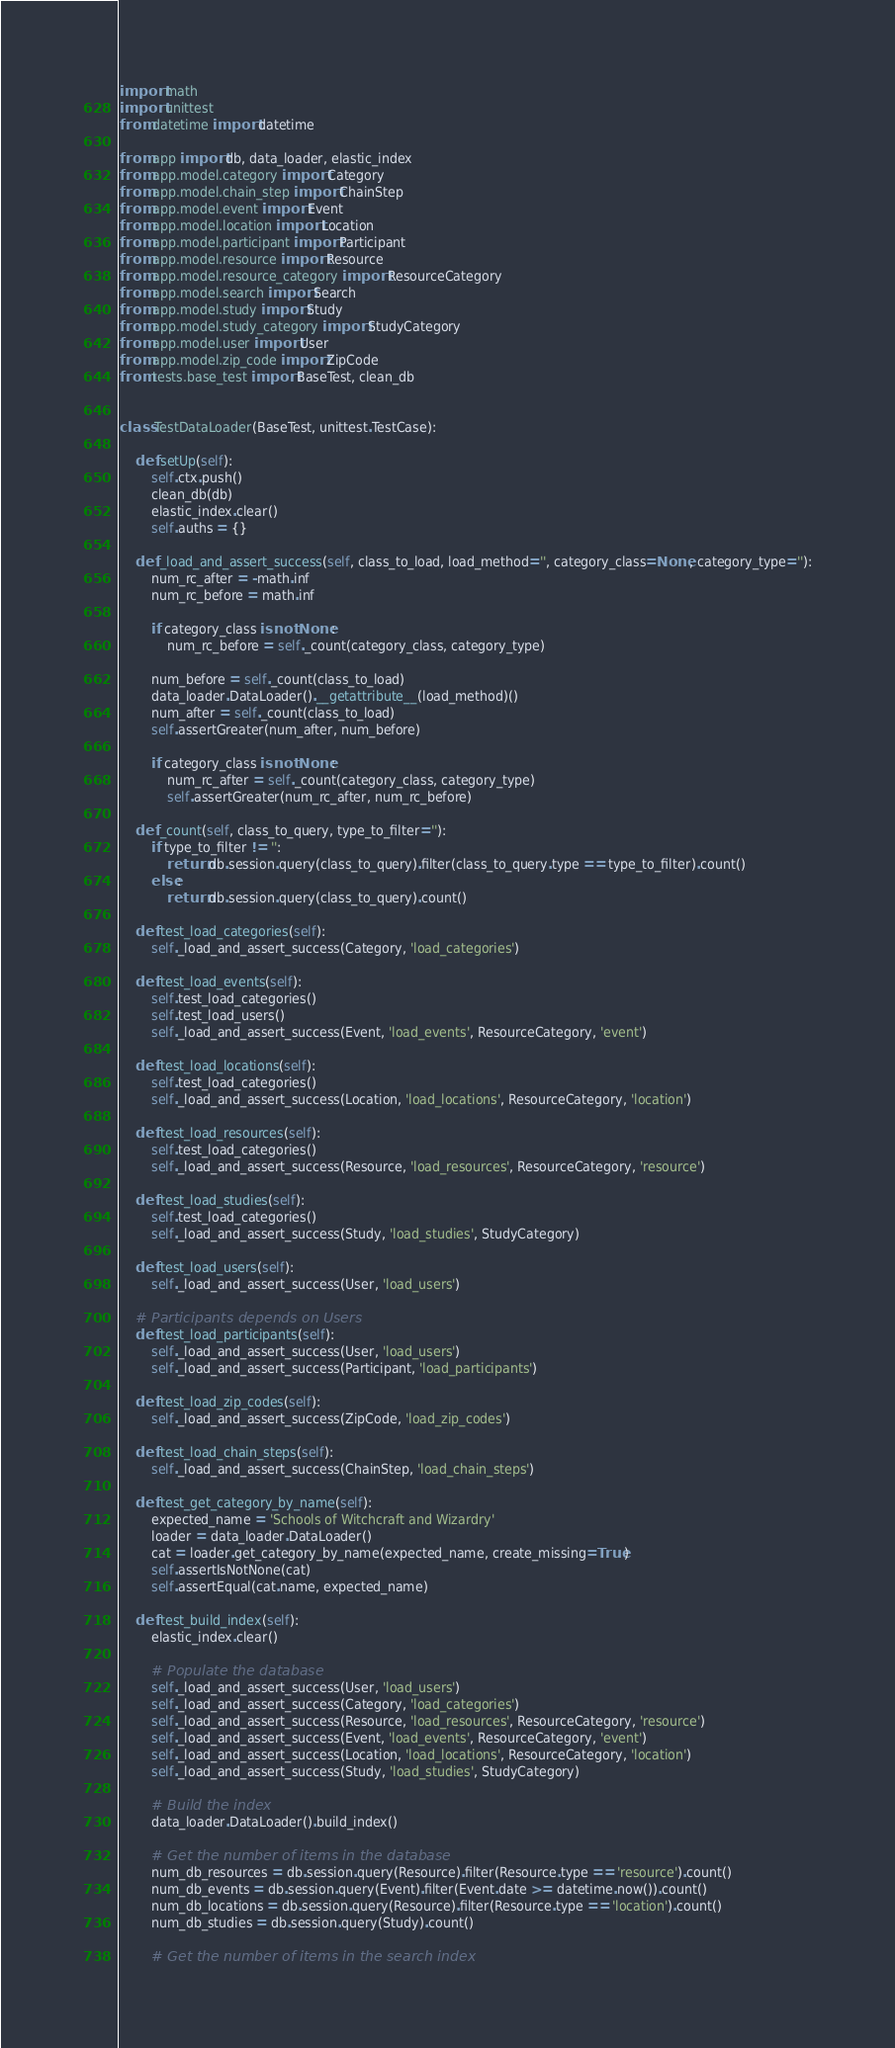Convert code to text. <code><loc_0><loc_0><loc_500><loc_500><_Python_>import math
import unittest
from datetime import datetime

from app import db, data_loader, elastic_index
from app.model.category import Category
from app.model.chain_step import ChainStep
from app.model.event import Event
from app.model.location import Location
from app.model.participant import Participant
from app.model.resource import Resource
from app.model.resource_category import ResourceCategory
from app.model.search import Search
from app.model.study import Study
from app.model.study_category import StudyCategory
from app.model.user import User
from app.model.zip_code import ZipCode
from tests.base_test import BaseTest, clean_db


class TestDataLoader(BaseTest, unittest.TestCase):

    def setUp(self):
        self.ctx.push()
        clean_db(db)
        elastic_index.clear()
        self.auths = {}

    def _load_and_assert_success(self, class_to_load, load_method='', category_class=None, category_type=''):
        num_rc_after = -math.inf
        num_rc_before = math.inf

        if category_class is not None:
            num_rc_before = self._count(category_class, category_type)

        num_before = self._count(class_to_load)
        data_loader.DataLoader().__getattribute__(load_method)()
        num_after = self._count(class_to_load)
        self.assertGreater(num_after, num_before)

        if category_class is not None:
            num_rc_after = self._count(category_class, category_type)
            self.assertGreater(num_rc_after, num_rc_before)

    def _count(self, class_to_query, type_to_filter=''):
        if type_to_filter != '':
            return db.session.query(class_to_query).filter(class_to_query.type == type_to_filter).count()
        else:
            return db.session.query(class_to_query).count()

    def test_load_categories(self):
        self._load_and_assert_success(Category, 'load_categories')

    def test_load_events(self):
        self.test_load_categories()
        self.test_load_users()
        self._load_and_assert_success(Event, 'load_events', ResourceCategory, 'event')

    def test_load_locations(self):
        self.test_load_categories()
        self._load_and_assert_success(Location, 'load_locations', ResourceCategory, 'location')

    def test_load_resources(self):
        self.test_load_categories()
        self._load_and_assert_success(Resource, 'load_resources', ResourceCategory, 'resource')

    def test_load_studies(self):
        self.test_load_categories()
        self._load_and_assert_success(Study, 'load_studies', StudyCategory)

    def test_load_users(self):
        self._load_and_assert_success(User, 'load_users')

    # Participants depends on Users
    def test_load_participants(self):
        self._load_and_assert_success(User, 'load_users')
        self._load_and_assert_success(Participant, 'load_participants')

    def test_load_zip_codes(self):
        self._load_and_assert_success(ZipCode, 'load_zip_codes')

    def test_load_chain_steps(self):
        self._load_and_assert_success(ChainStep, 'load_chain_steps')

    def test_get_category_by_name(self):
        expected_name = 'Schools of Witchcraft and Wizardry'
        loader = data_loader.DataLoader()
        cat = loader.get_category_by_name(expected_name, create_missing=True)
        self.assertIsNotNone(cat)
        self.assertEqual(cat.name, expected_name)

    def test_build_index(self):
        elastic_index.clear()

        # Populate the database
        self._load_and_assert_success(User, 'load_users')
        self._load_and_assert_success(Category, 'load_categories')
        self._load_and_assert_success(Resource, 'load_resources', ResourceCategory, 'resource')
        self._load_and_assert_success(Event, 'load_events', ResourceCategory, 'event')
        self._load_and_assert_success(Location, 'load_locations', ResourceCategory, 'location')
        self._load_and_assert_success(Study, 'load_studies', StudyCategory)

        # Build the index
        data_loader.DataLoader().build_index()

        # Get the number of items in the database
        num_db_resources = db.session.query(Resource).filter(Resource.type == 'resource').count()
        num_db_events = db.session.query(Event).filter(Event.date >= datetime.now()).count()
        num_db_locations = db.session.query(Resource).filter(Resource.type == 'location').count()
        num_db_studies = db.session.query(Study).count()

        # Get the number of items in the search index</code> 